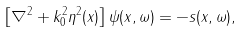Convert formula to latex. <formula><loc_0><loc_0><loc_500><loc_500>\left [ \nabla ^ { 2 } + k _ { 0 } ^ { 2 } \eta ^ { 2 } ( x ) \right ] \psi ( x , \omega ) = - s ( x , \omega ) ,</formula> 